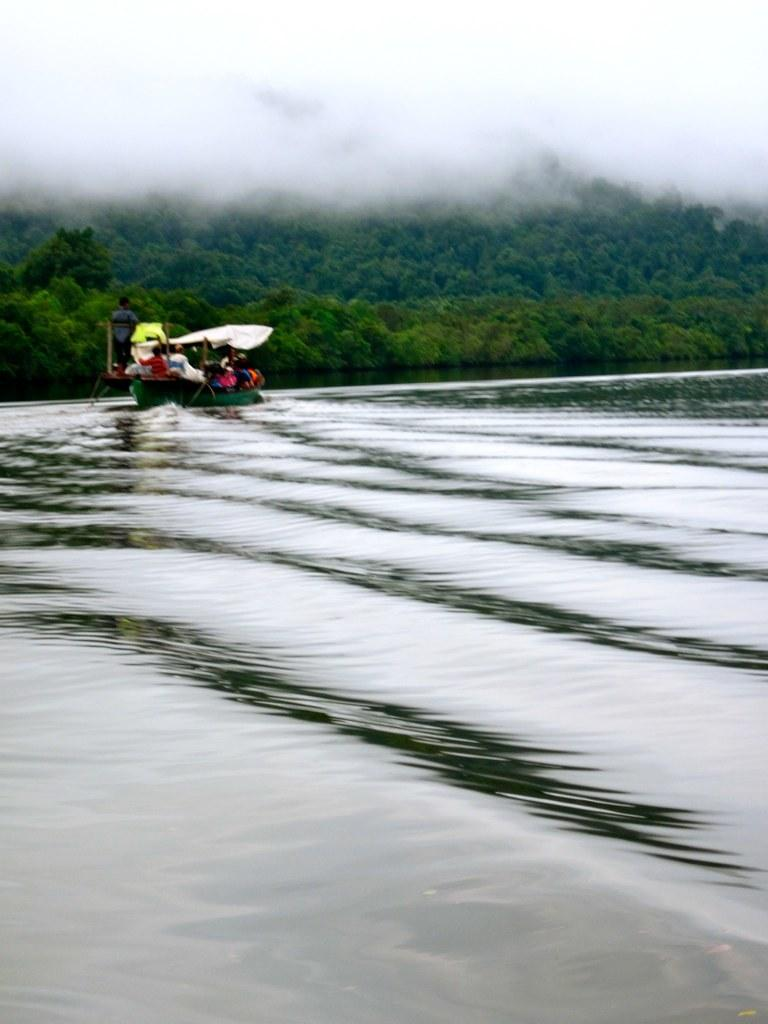What is the main subject of the image? The main subject of the image is water. What is located in the water? There is a boat in the water. Who is on the boat? There are people sitting on the boat. What can be seen in the background of the image? There are plants, trees, and fog in the background of the image. What type of sweater is being worn by the nut in the image? There is no sweater or nut present in the image. 